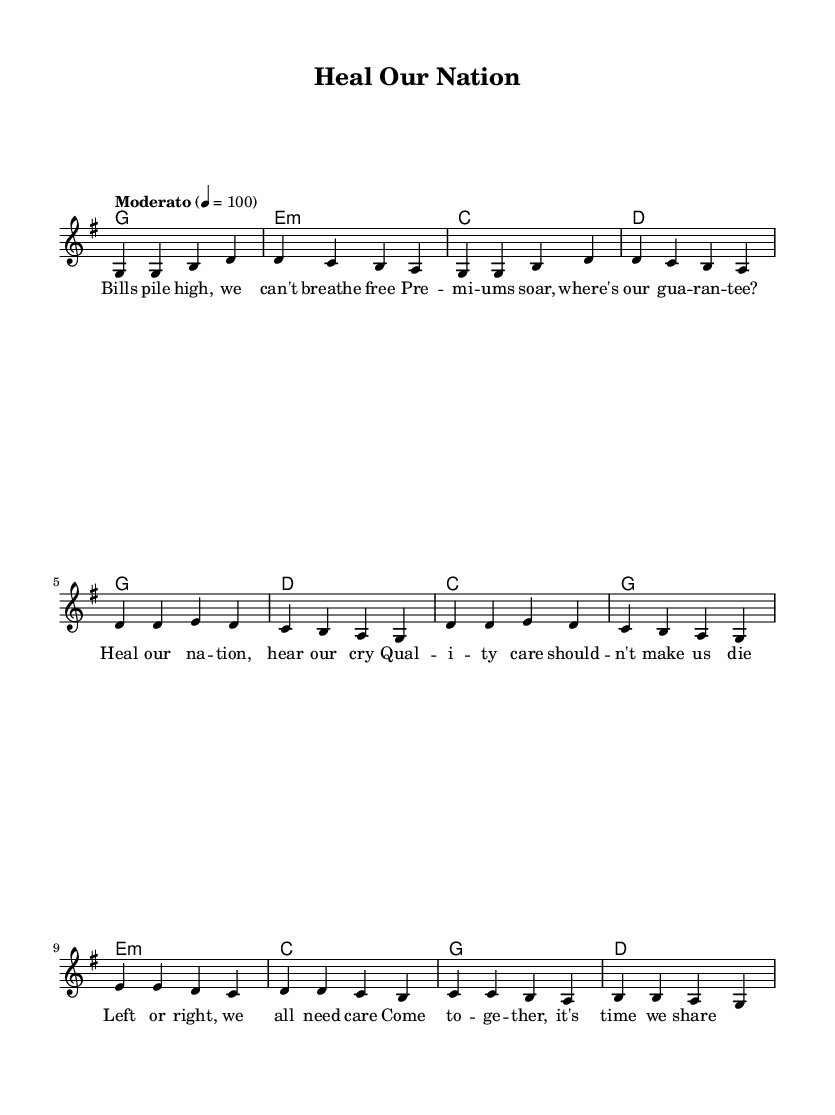What is the key signature of this music? The key signature is G major, which has one sharp (F#).
Answer: G major What is the time signature of this piece? The time signature is 4/4, indicating four beats per measure.
Answer: 4/4 What is the tempo marking for this song? The tempo marking indicates a moderate speed of 100 beats per minute.
Answer: Moderato 100 How many measures are in the verse section? The verse consists of 4 measures as indicated by the repetition of melodic phrases.
Answer: 4 Which chord is played during the chorus on the first beat of the first measure? The first chord in the chorus is G major (the root chord of this piece).
Answer: G What lyrical theme is addressed in the bridge section? The bridge section emphasizes unity and shared responsibility for healthcare.
Answer: Unity What type of song is "Heal Our Nation"? This song is categorized as a protest song, focusing on healthcare policies.
Answer: Protest song 